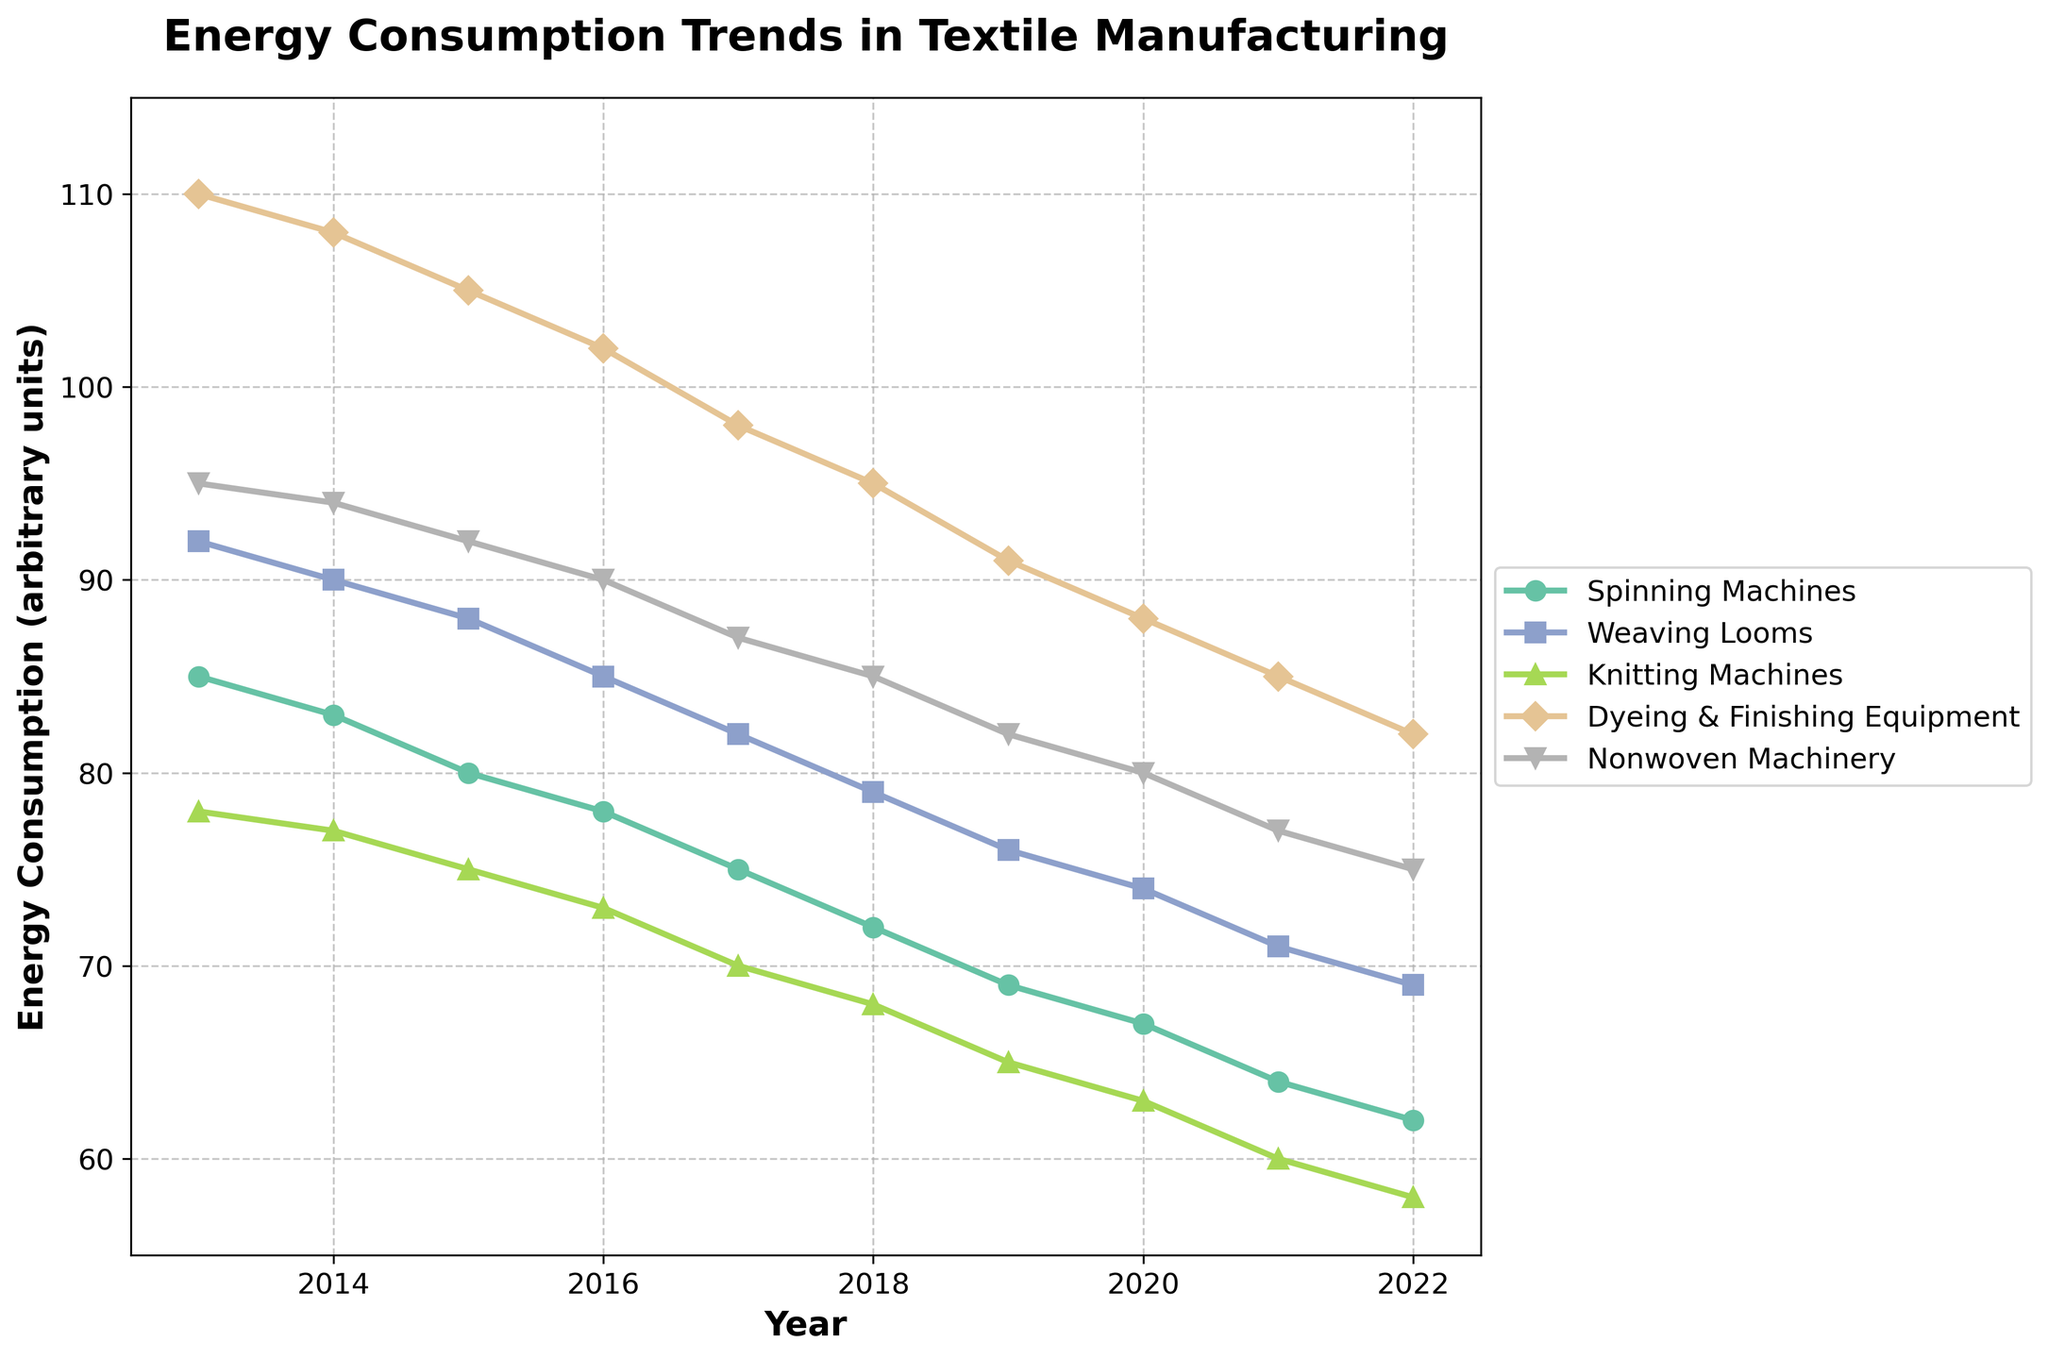What is the general trend of energy consumption for Spinning Machines over the past decade? The line chart shows a downward trend for Spinning Machines, indicating that energy consumption has decreased from 85 units in 2013 to 62 units in 2022.
Answer: Decreasing Which machinery type had the highest energy consumption in 2014? By observing the heights of the lines for each machinery type in 2014, Dyeing & Finishing Equipment stands out with the highest energy consumption of 108 units.
Answer: Dyeing & Finishing Equipment What is the total energy consumption for Weaving Looms from 2017 to 2022? Sum the energy consumption values for Weaving Looms from 2017 to 2022 (82 + 79 + 76 + 74 + 71 + 69). So, 451 units.
Answer: 451 Which machinery type showed a faster decline in energy consumption between 2013 and 2022: Spinning Machines or Dyeing & Finishing Equipment? Compare the drop in energy consumption from 2013 to 2022 for both Spinning Machines (85 to 62, a drop of 23 units) and Dyeing & Finishing Equipment (110 to 82, a drop of 28 units). Dyeing & Finishing Equipment had a larger decrease.
Answer: Dyeing & Finishing Equipment What is the average energy consumption of Knitting Machines over the past decade? Calculate the average by summing the energy consumption values (78 + 77 + 75 + 73 + 70 + 68 + 65 + 63 + 60 + 58) and dividing by the number of years (10). Thus, (687/10) = 68.7 units.
Answer: 68.7 units In which year did Nonwoven Machinery’s energy consumption fall below 80 units? By observing the line for Nonwoven Machinery, it fell below 80 units in 2020, where it recorded 80 units compared to 82 units in 2019.
Answer: 2020 Compare the energy consumption of Weaving Looms and Knitting Machines in the year 2018. Which consumed more energy? By observing the 2018 values from the chart, Weaving Looms had an energy consumption of 79 units while Knitting Machines had 68 units; thus, Weaving Looms consumed more energy.
Answer: Weaving Looms What is the difference in energy consumption between the highest and lowest consuming machinery types in 2022? In 2022, Dyeing & Finishing Equipment consumed the most (82 units) while Knitting Machines consumed the least (58 units). The difference is 82 - 58 = 24 units.
Answer: 24 units Which machinery type had consistently declining energy consumption every year? By carefully observing all machinery types, all of them show a consistent decline in energy consumption year by year.
Answer: All types 